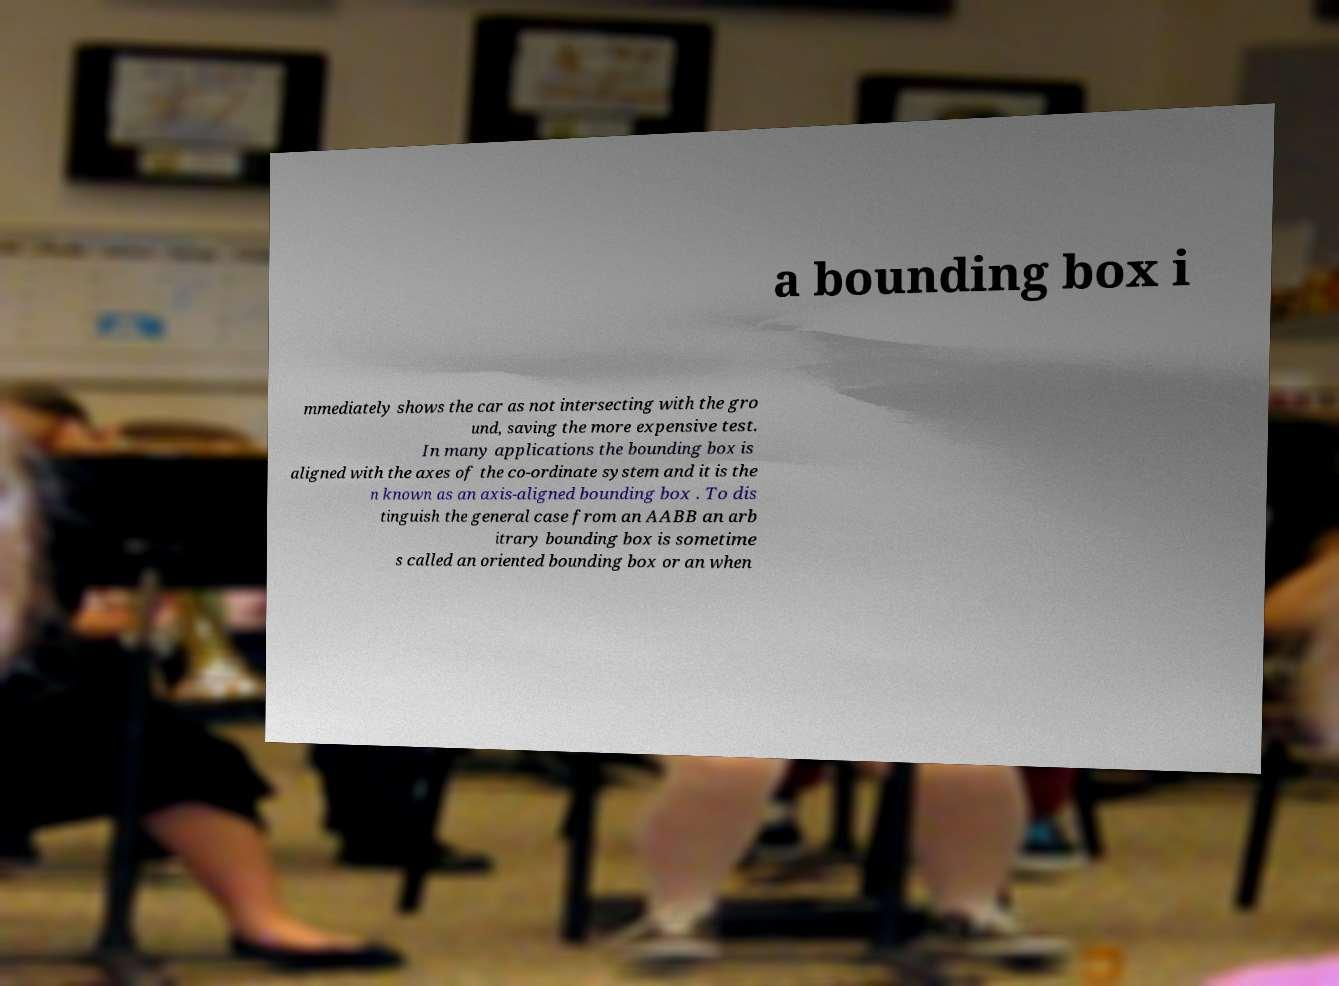There's text embedded in this image that I need extracted. Can you transcribe it verbatim? a bounding box i mmediately shows the car as not intersecting with the gro und, saving the more expensive test. In many applications the bounding box is aligned with the axes of the co-ordinate system and it is the n known as an axis-aligned bounding box . To dis tinguish the general case from an AABB an arb itrary bounding box is sometime s called an oriented bounding box or an when 